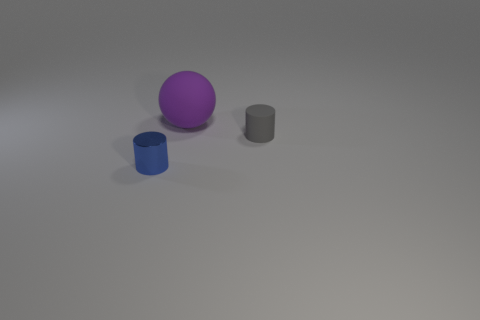Add 3 large purple spheres. How many objects exist? 6 Subtract all cylinders. How many objects are left? 1 Subtract 0 red balls. How many objects are left? 3 Subtract all spheres. Subtract all matte objects. How many objects are left? 0 Add 3 tiny cylinders. How many tiny cylinders are left? 5 Add 2 large red shiny objects. How many large red shiny objects exist? 2 